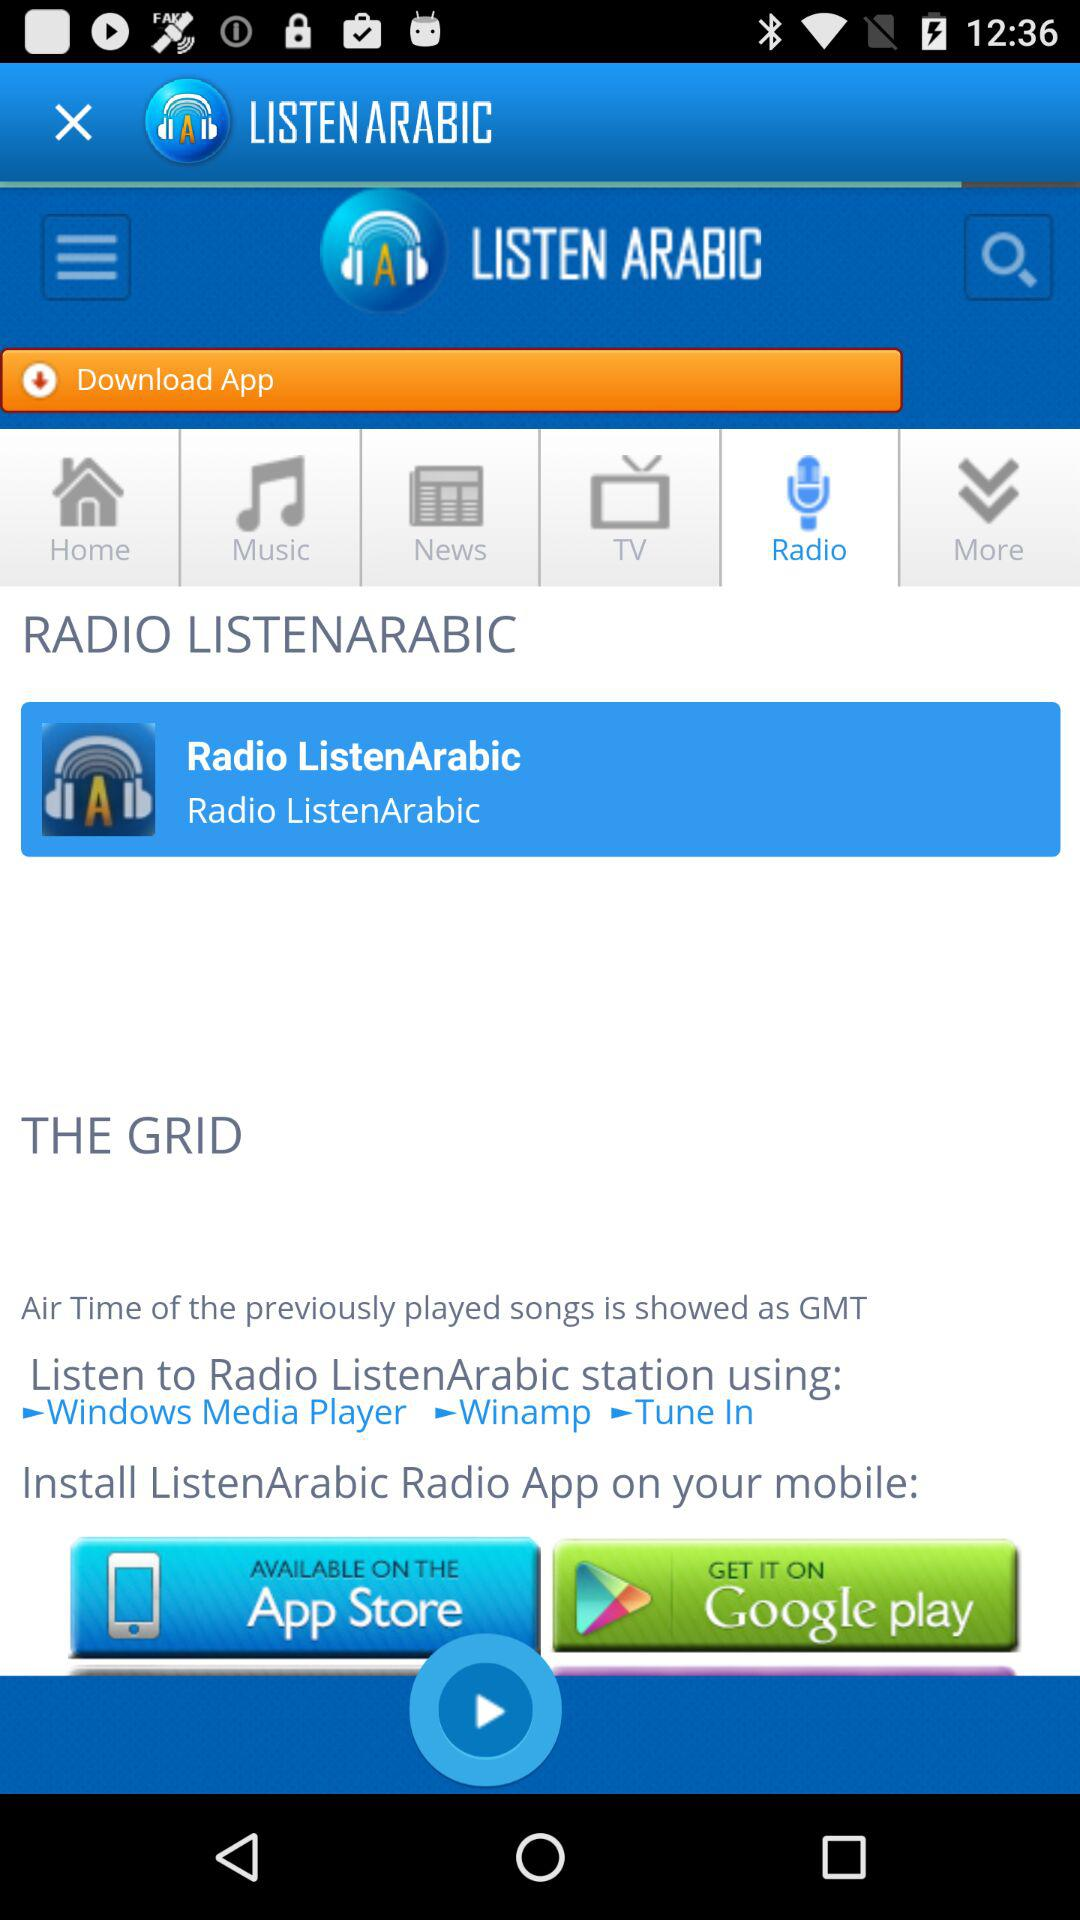Which tab is selected? The selected tab is "Radio". 